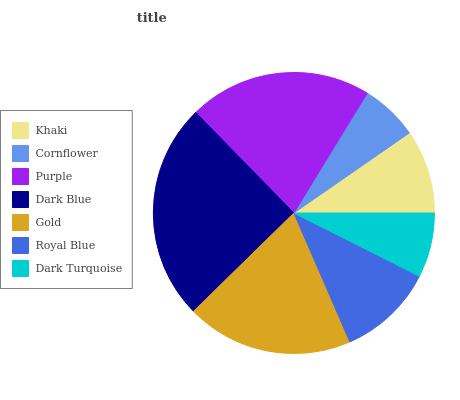Is Cornflower the minimum?
Answer yes or no. Yes. Is Dark Blue the maximum?
Answer yes or no. Yes. Is Purple the minimum?
Answer yes or no. No. Is Purple the maximum?
Answer yes or no. No. Is Purple greater than Cornflower?
Answer yes or no. Yes. Is Cornflower less than Purple?
Answer yes or no. Yes. Is Cornflower greater than Purple?
Answer yes or no. No. Is Purple less than Cornflower?
Answer yes or no. No. Is Royal Blue the high median?
Answer yes or no. Yes. Is Royal Blue the low median?
Answer yes or no. Yes. Is Dark Blue the high median?
Answer yes or no. No. Is Cornflower the low median?
Answer yes or no. No. 